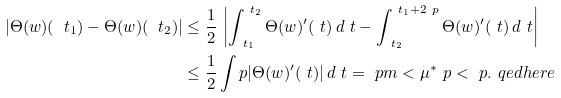Convert formula to latex. <formula><loc_0><loc_0><loc_500><loc_500>| \Theta ( w ) ( \ t _ { 1 } ) - \Theta ( w ) ( \ t _ { 2 } ) | & \leq \frac { 1 } { 2 } \, \left | \int _ { \ t _ { 1 } } ^ { \ t _ { 2 } } \Theta ( w ) ^ { \prime } ( \ t ) \, d \ t - \int _ { \ t _ { 2 } } ^ { \ t _ { 1 } + 2 \ p } \Theta ( w ) ^ { \prime } ( \ t ) \, d \ t \right | \\ & \leq \frac { 1 } { 2 } \int p | \Theta ( w ) ^ { \prime } ( \ t ) | \, d \ t = \ p m < \mu ^ { * } \ p < \ p . \ q e d h e r e</formula> 